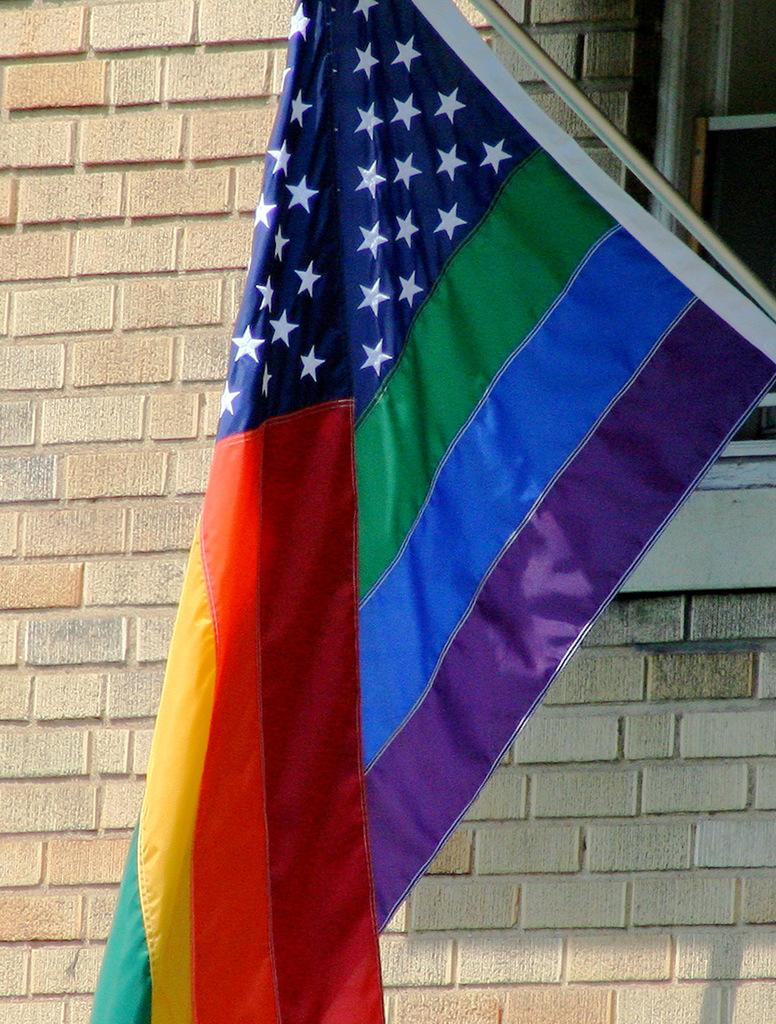What can be seen in the image that represents a symbol or country? There is a flag in the image. What is visible in the background of the image? There is a wall and a window in the background of the image. What degree does the doctor hold, as seen in the image? There is no doctor or degree present in the image; it only features a flag and a wall with a window in the background. 